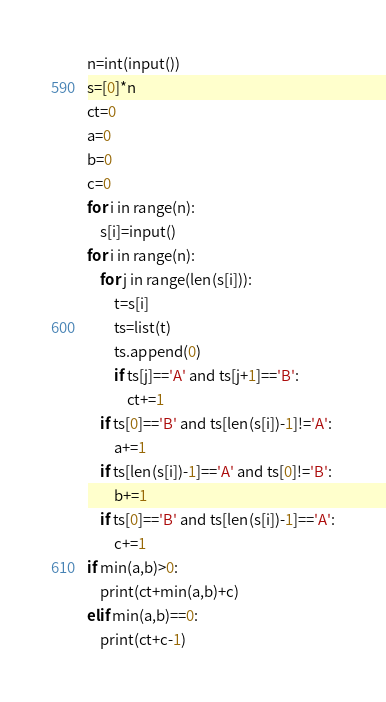<code> <loc_0><loc_0><loc_500><loc_500><_Python_>n=int(input())
s=[0]*n
ct=0
a=0
b=0
c=0
for i in range(n):
    s[i]=input()
for i in range(n):
    for j in range(len(s[i])):
        t=s[i]
        ts=list(t)
        ts.append(0)
        if ts[j]=='A' and ts[j+1]=='B':
            ct+=1
    if ts[0]=='B' and ts[len(s[i])-1]!='A':
        a+=1
    if ts[len(s[i])-1]=='A' and ts[0]!='B':
        b+=1
    if ts[0]=='B' and ts[len(s[i])-1]=='A':
        c+=1
if min(a,b)>0:
    print(ct+min(a,b)+c)
elif min(a,b)==0:
    print(ct+c-1)</code> 